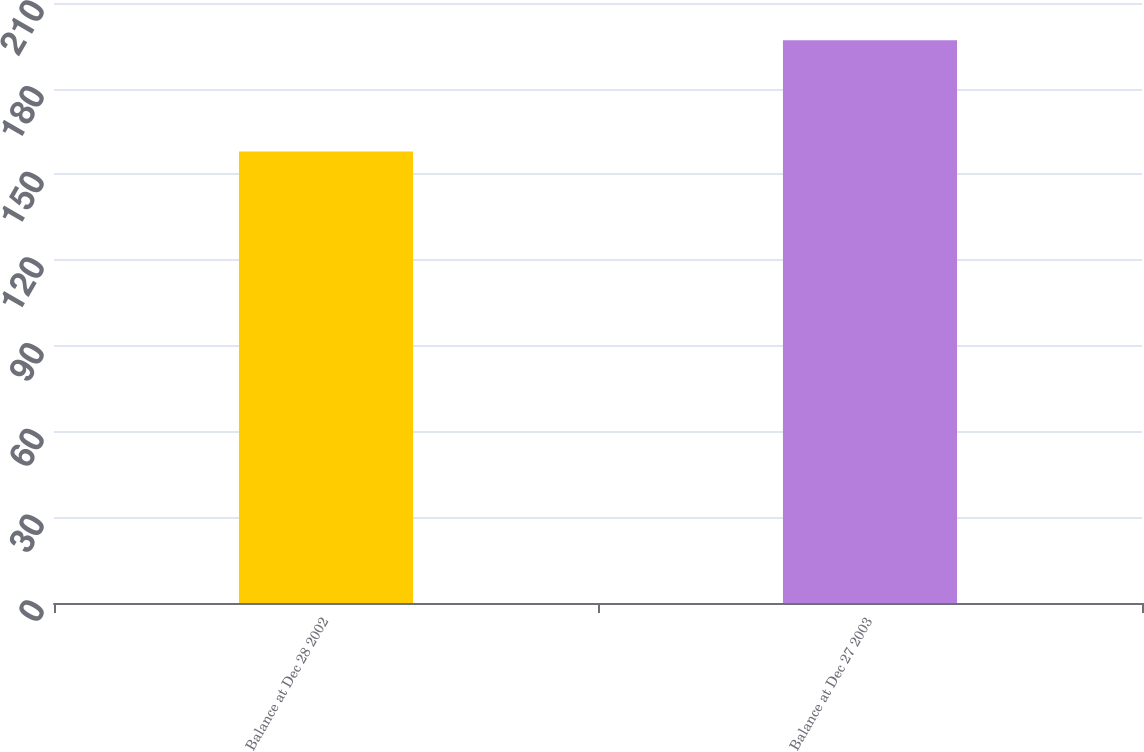<chart> <loc_0><loc_0><loc_500><loc_500><bar_chart><fcel>Balance at Dec 28 2002<fcel>Balance at Dec 27 2003<nl><fcel>158<fcel>197<nl></chart> 